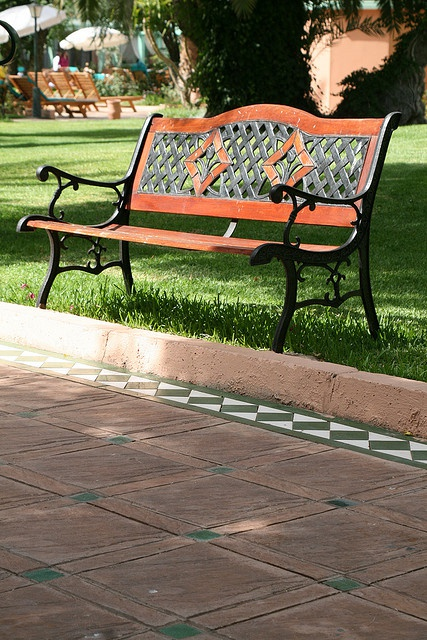Describe the objects in this image and their specific colors. I can see bench in olive, black, darkgreen, salmon, and darkgray tones, umbrella in olive, white, darkgray, tan, and black tones, and umbrella in olive, white, tan, darkgray, and gray tones in this image. 